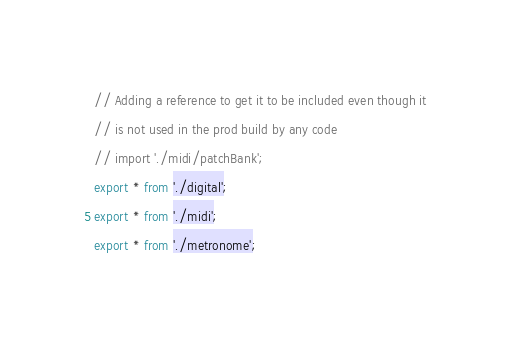Convert code to text. <code><loc_0><loc_0><loc_500><loc_500><_TypeScript_>// Adding a reference to get it to be included even though it
// is not used in the prod build by any code
// import './midi/patchBank';
export * from './digital';
export * from './midi';
export * from './metronome';
</code> 